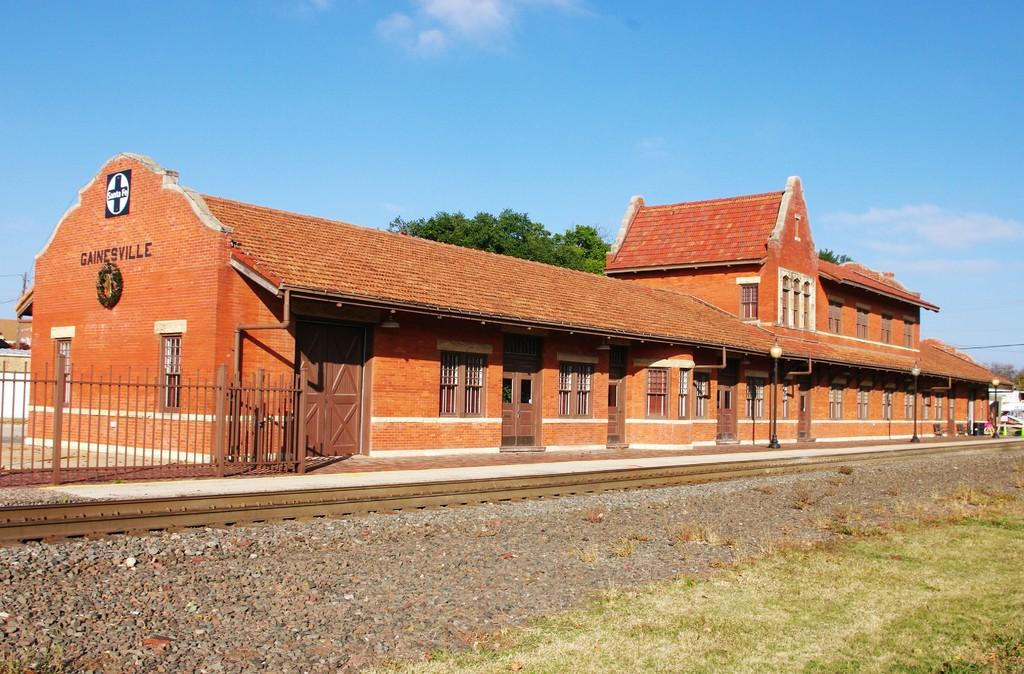Where was the image taken? The image was clicked outside. What is the main subject in the middle of the image? There is a building in the middle of the image. What features can be seen on the building? The building has doors and windows. What other object is present in the middle of the image? There is a tree in the middle of the image. What is visible at the top of the image? The sky is visible at the top of the image. What is the condition of the teeth of the tree in the image? There are no teeth present in the image, as trees do not have teeth. 